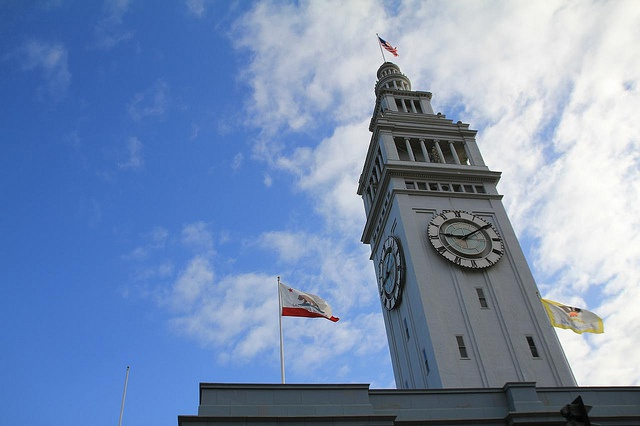Describe the objects in this image and their specific colors. I can see clock in blue, gray, and black tones and clock in blue, black, and gray tones in this image. 